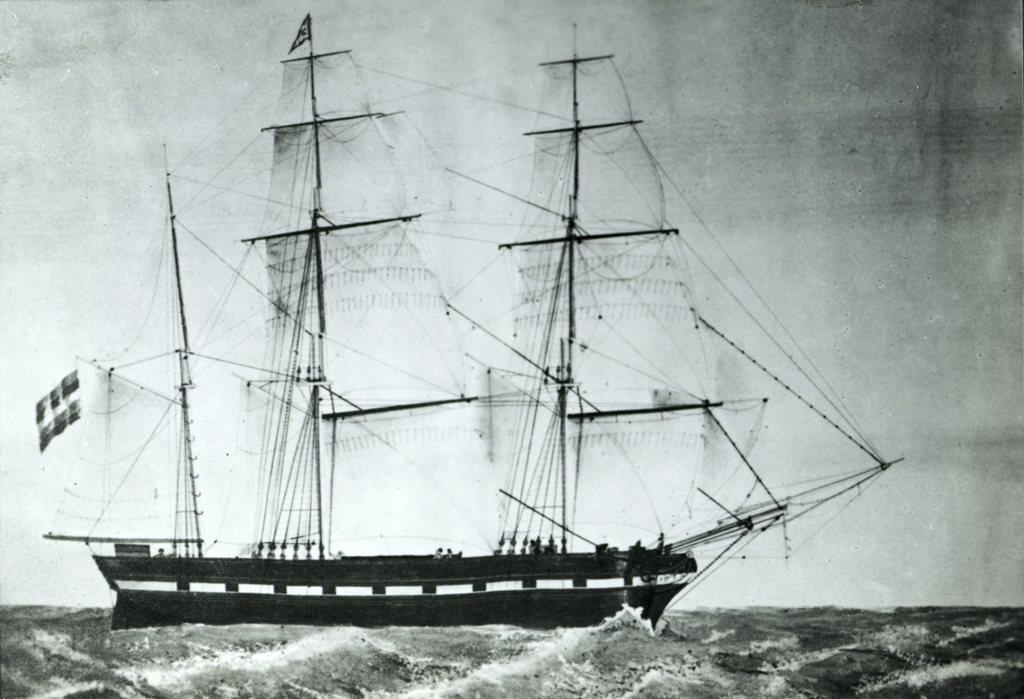What type of picture is in the image? The image contains a black and white picture. What is the subject of the picture? The picture depicts a boat. What else can be seen in the image besides the boat? There is a group of poles and cables present in the water in the image. What memories does the boat in the image evoke for the viewer? The image does not provide any information about the viewer's memories or emotions, so it is impossible to answer this question. 